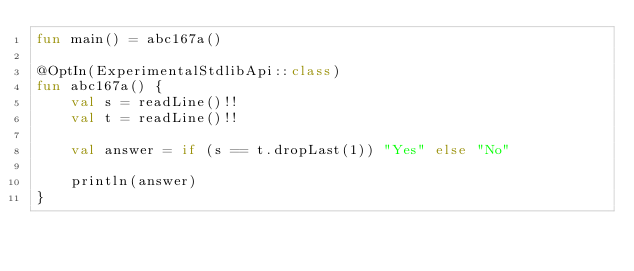Convert code to text. <code><loc_0><loc_0><loc_500><loc_500><_Kotlin_>fun main() = abc167a()

@OptIn(ExperimentalStdlibApi::class)
fun abc167a() {
    val s = readLine()!!
    val t = readLine()!!

    val answer = if (s == t.dropLast(1)) "Yes" else "No"

    println(answer)
}
</code> 